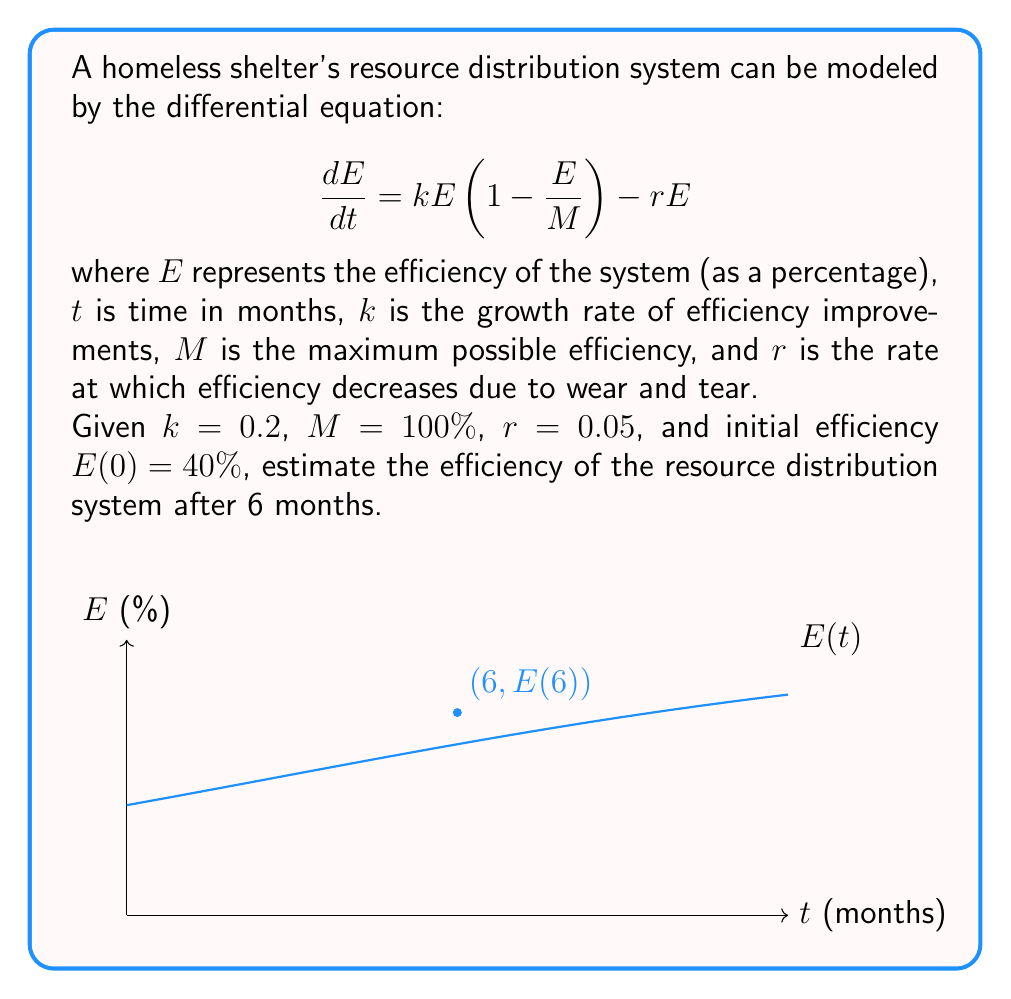Teach me how to tackle this problem. To solve this problem, we'll use the following steps:

1) First, we recognize this as a logistic differential equation with an additional decay term. The solution to this type of equation is not trivial, but we can use Euler's method to approximate the solution numerically.

2) Euler's method is given by the formula:
   $$E_{n+1} = E_n + h \cdot f(t_n, E_n)$$
   where $h$ is the step size and $f(t,E) = kE(1-\frac{E}{M}) - rE$

3) We'll use a step size of $h=1$ month, so we'll calculate 6 steps.

4) Let's calculate each step:

   At $t=0$: $E_0 = 40$
   
   At $t=1$: $E_1 = 40 + 1 \cdot (0.2 \cdot 40 \cdot (1-\frac{40}{100}) - 0.05 \cdot 40) = 44.8$
   
   At $t=2$: $E_2 = 44.8 + 1 \cdot (0.2 \cdot 44.8 \cdot (1-\frac{44.8}{100}) - 0.05 \cdot 44.8) = 49.18$
   
   At $t=3$: $E_3 = 49.18 + 1 \cdot (0.2 \cdot 49.18 \cdot (1-\frac{49.18}{100}) - 0.05 \cdot 49.18) = 53.13$
   
   At $t=4$: $E_4 = 53.13 + 1 \cdot (0.2 \cdot 53.13 \cdot (1-\frac{53.13}{100}) - 0.05 \cdot 53.13) = 56.64$
   
   At $t=5$: $E_5 = 56.64 + 1 \cdot (0.2 \cdot 56.64 \cdot (1-\frac{56.64}{100}) - 0.05 \cdot 56.64) = 59.73$
   
   At $t=6$: $E_6 = 59.73 + 1 \cdot (0.2 \cdot 59.73 \cdot (1-\frac{59.73}{100}) - 0.05 \cdot 59.73) = 62.41$

5) Therefore, after 6 months, the efficiency is estimated to be approximately 62.41%.
Answer: 62.41% 